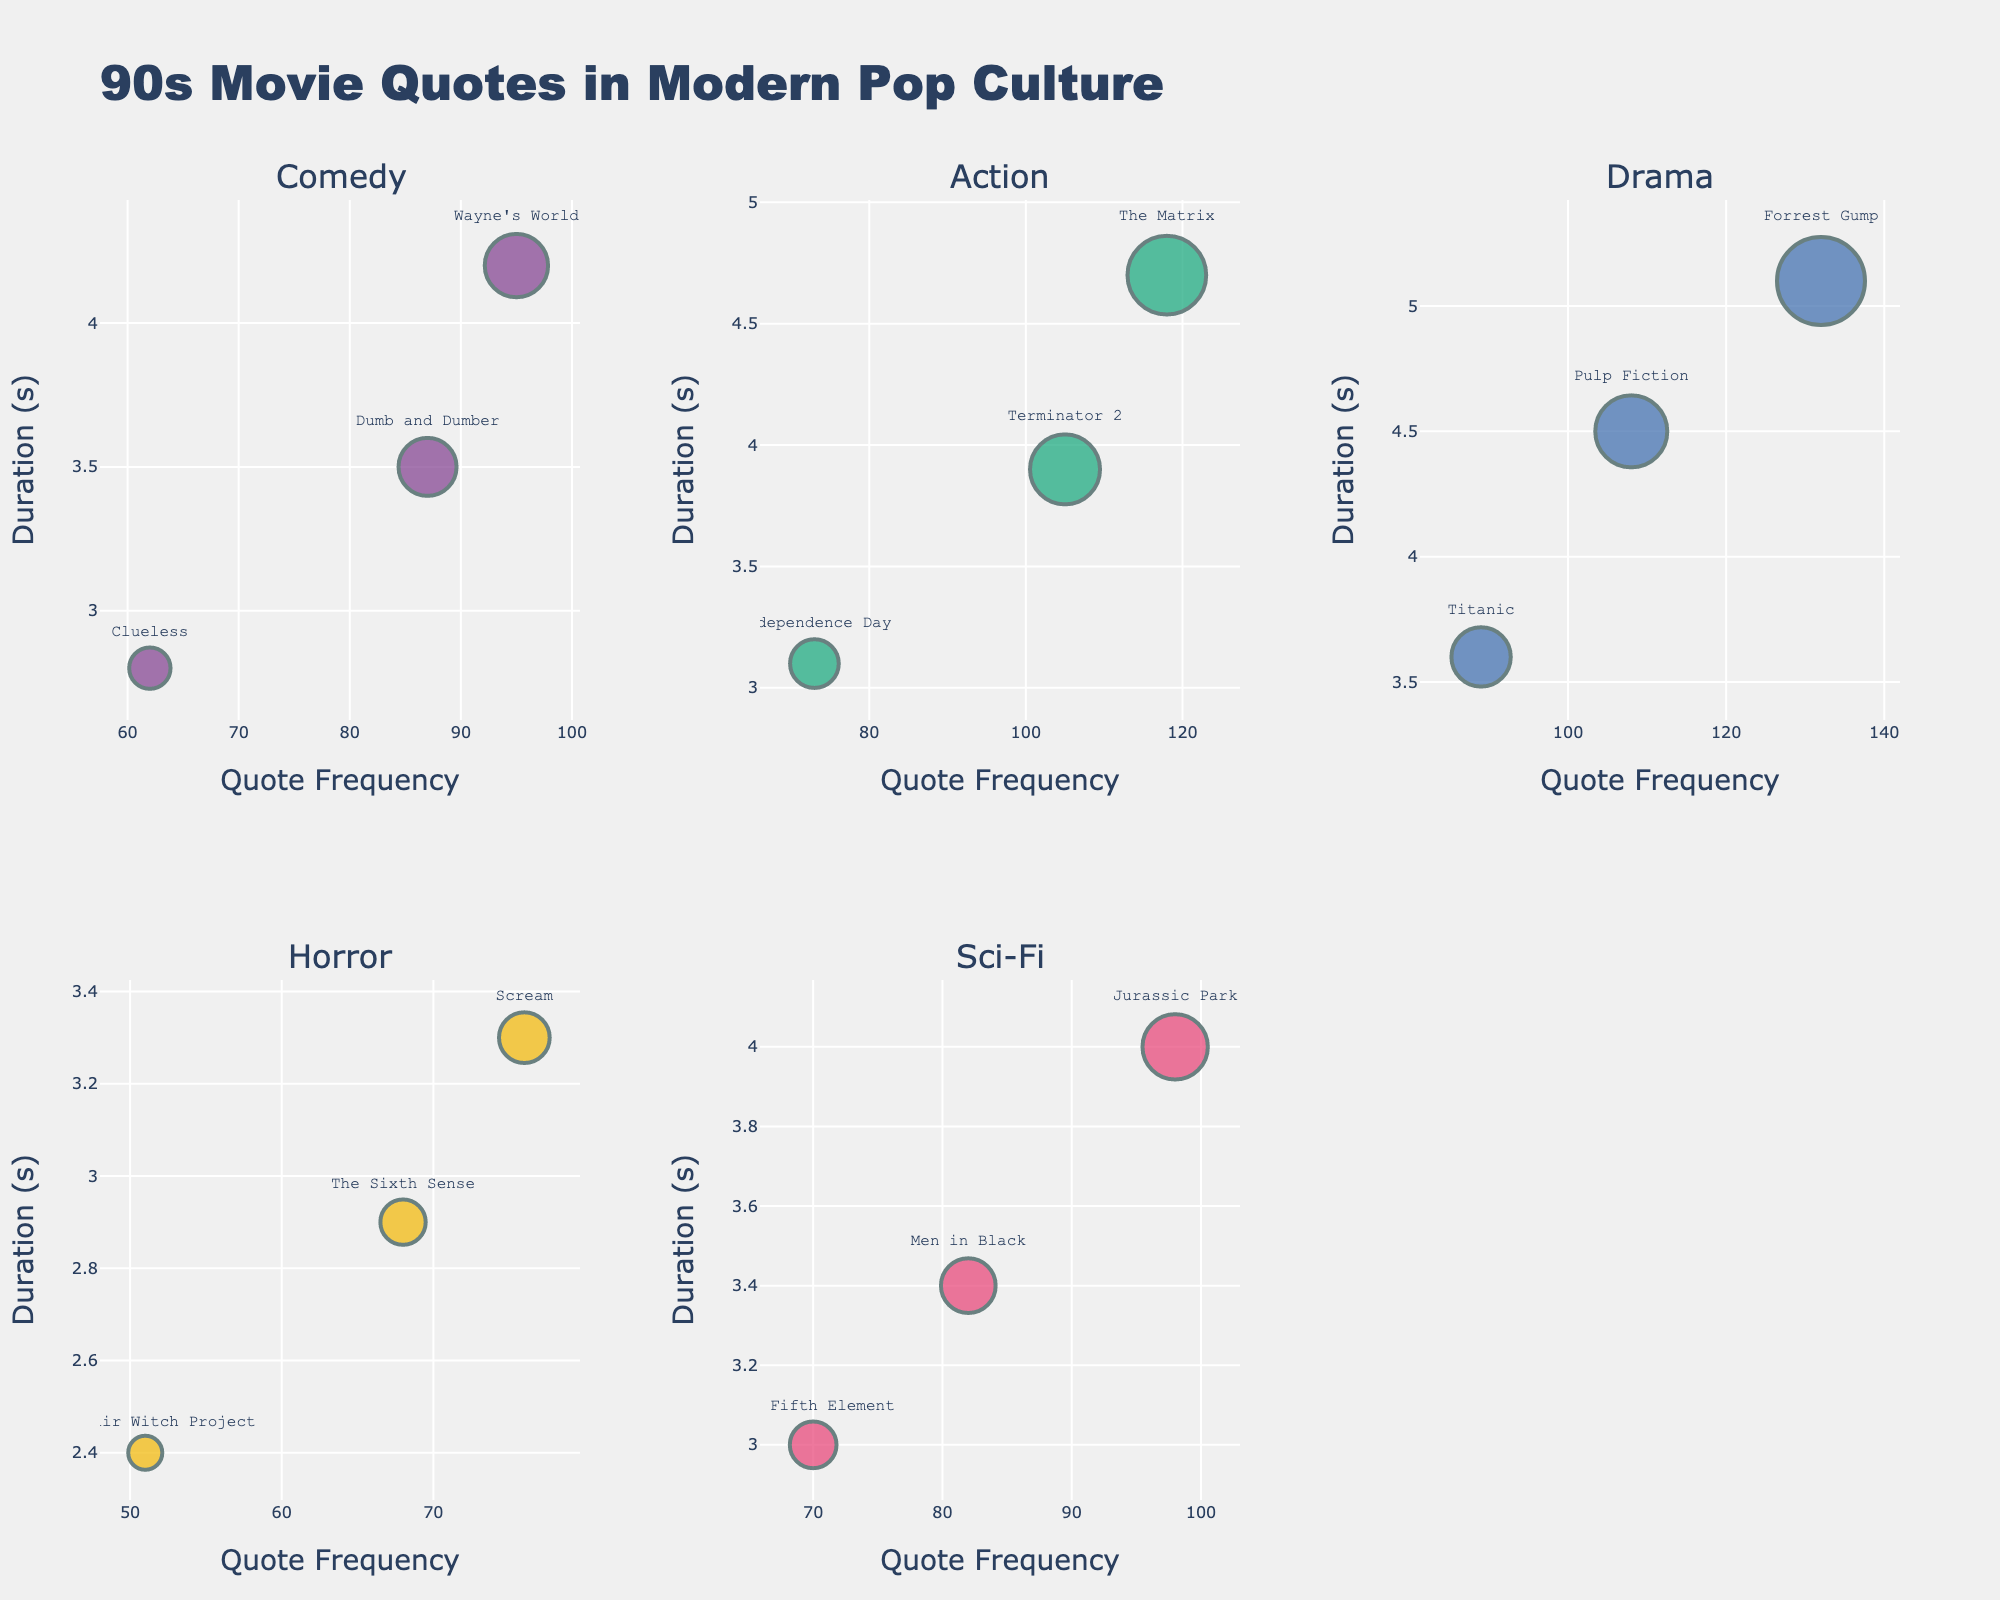How many genres are displayed in the figure? Count the number of unique subplot titles in the figure, each representing a different genre.
Answer: 5 What is the title of the figure? Refer to the large text at the top center of the figure.
Answer: 90s Movie Quotes in Modern Pop Culture Which genre has the highest quote frequency for any single movie? Find the genre with the movie featuring the highest x-axis value (Quote Frequency) across all subplots.
Answer: Drama What is the average quote duration (in seconds) for Comedy movies? Sum the Quote_Duration_Seconds values for Comedy movies (3.5, 2.8, 4.2) and divide by the number of Comedy movies (3).
Answer: (3.5 + 2.8 + 4.2) / 3 = 3.5 Which movie in the Sci-Fi genre has the shortest quote duration? Look at the lowest y-axis value (Quote Duration) within the Sci-Fi genre subplot.
Answer: The Fifth Element Compare the quote frequency of "Jurassic Park" and "Men in Black". Which one is higher? Compare the x-axis values of "Jurassic Park" and "Men in Black" in the Sci-Fi genre subplot.
Answer: Jurassic Park What is the sum of all quote frequencies from the Horror genre? Add up the Quote_Frequency values for all Horror movies (76, 68, 51).
Answer: 76 + 68 + 51 = 195 In the Action genre, which movie has the longest quote duration? Look for the highest y-axis value (Quote Duration) in the Action genre subplot.
Answer: The Matrix How does the quote frequency of "Forrest Gump" compare to "Pulp Fiction"? Compare the x-axis values in the Drama genre subplot for "Forrest Gump" and "Pulp Fiction".
Answer: Forrest Gump has a higher frequency In terms of quote frequency, what is the largest difference between any two movies within the same genre? Identify the genre with the largest absolute difference in x-axis values between any two movies within that genre.
Answer: Drama (132 - 89 = 43) 